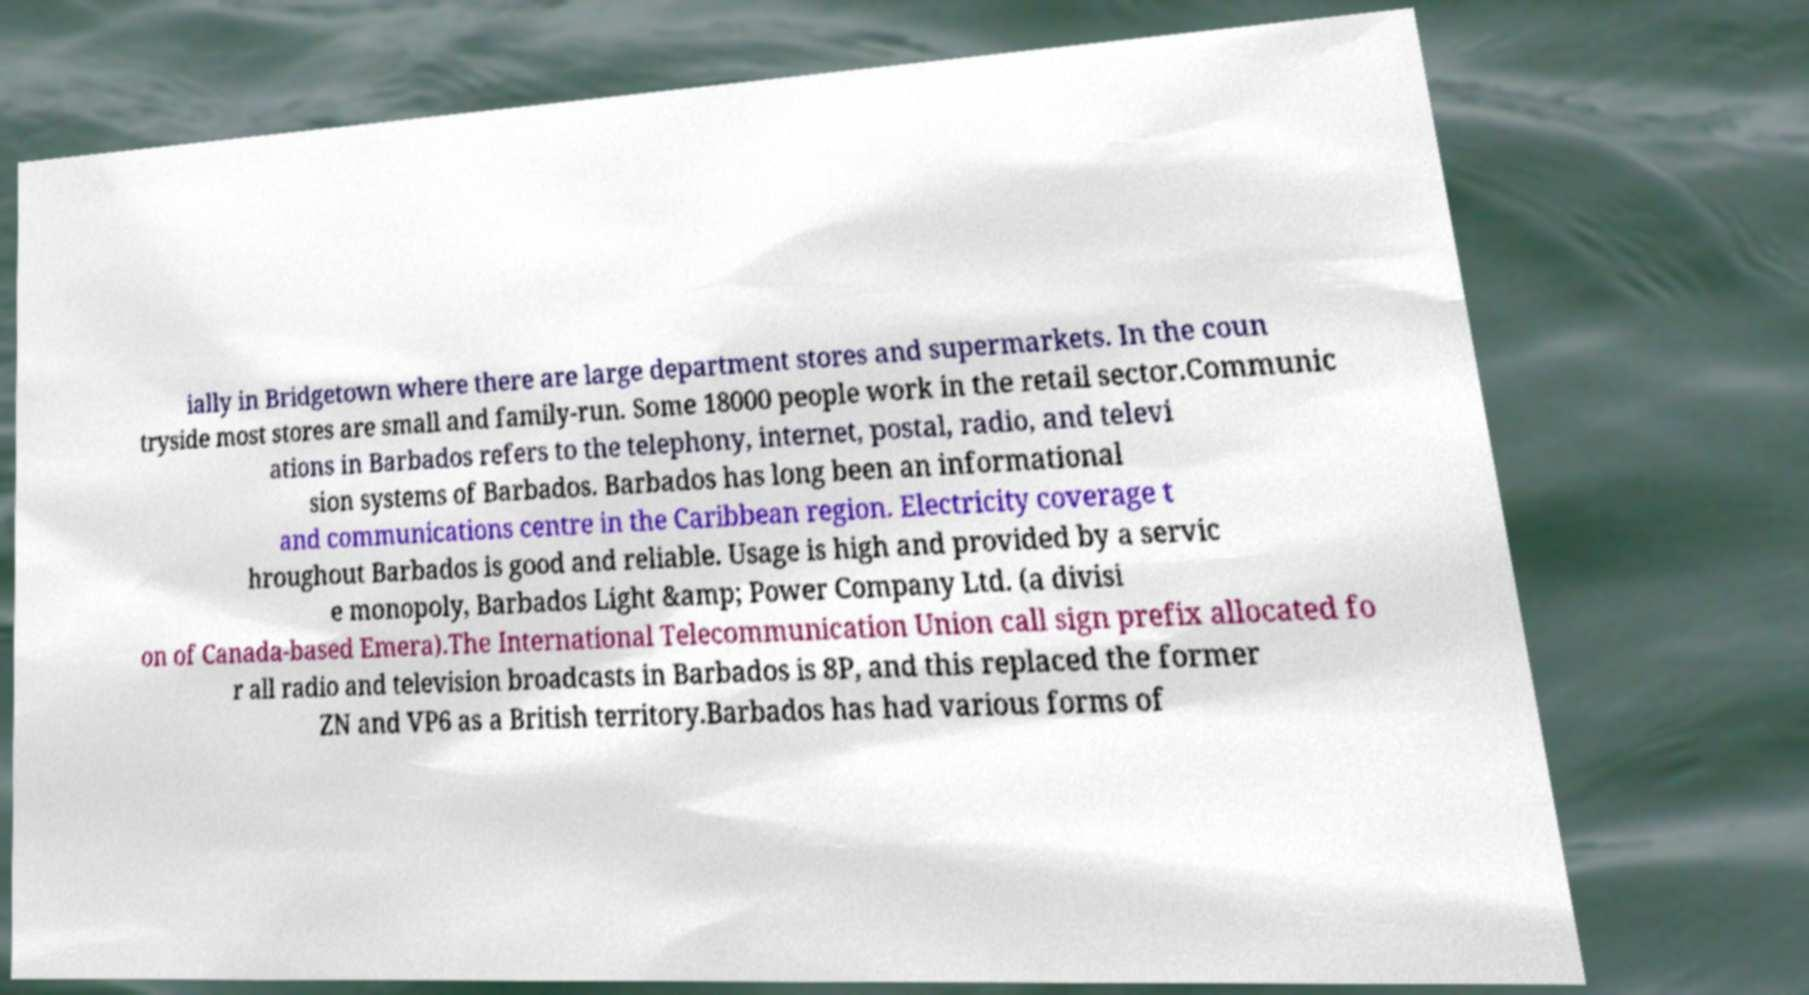Can you read and provide the text displayed in the image?This photo seems to have some interesting text. Can you extract and type it out for me? ially in Bridgetown where there are large department stores and supermarkets. In the coun tryside most stores are small and family-run. Some 18000 people work in the retail sector.Communic ations in Barbados refers to the telephony, internet, postal, radio, and televi sion systems of Barbados. Barbados has long been an informational and communications centre in the Caribbean region. Electricity coverage t hroughout Barbados is good and reliable. Usage is high and provided by a servic e monopoly, Barbados Light &amp; Power Company Ltd. (a divisi on of Canada-based Emera).The International Telecommunication Union call sign prefix allocated fo r all radio and television broadcasts in Barbados is 8P, and this replaced the former ZN and VP6 as a British territory.Barbados has had various forms of 